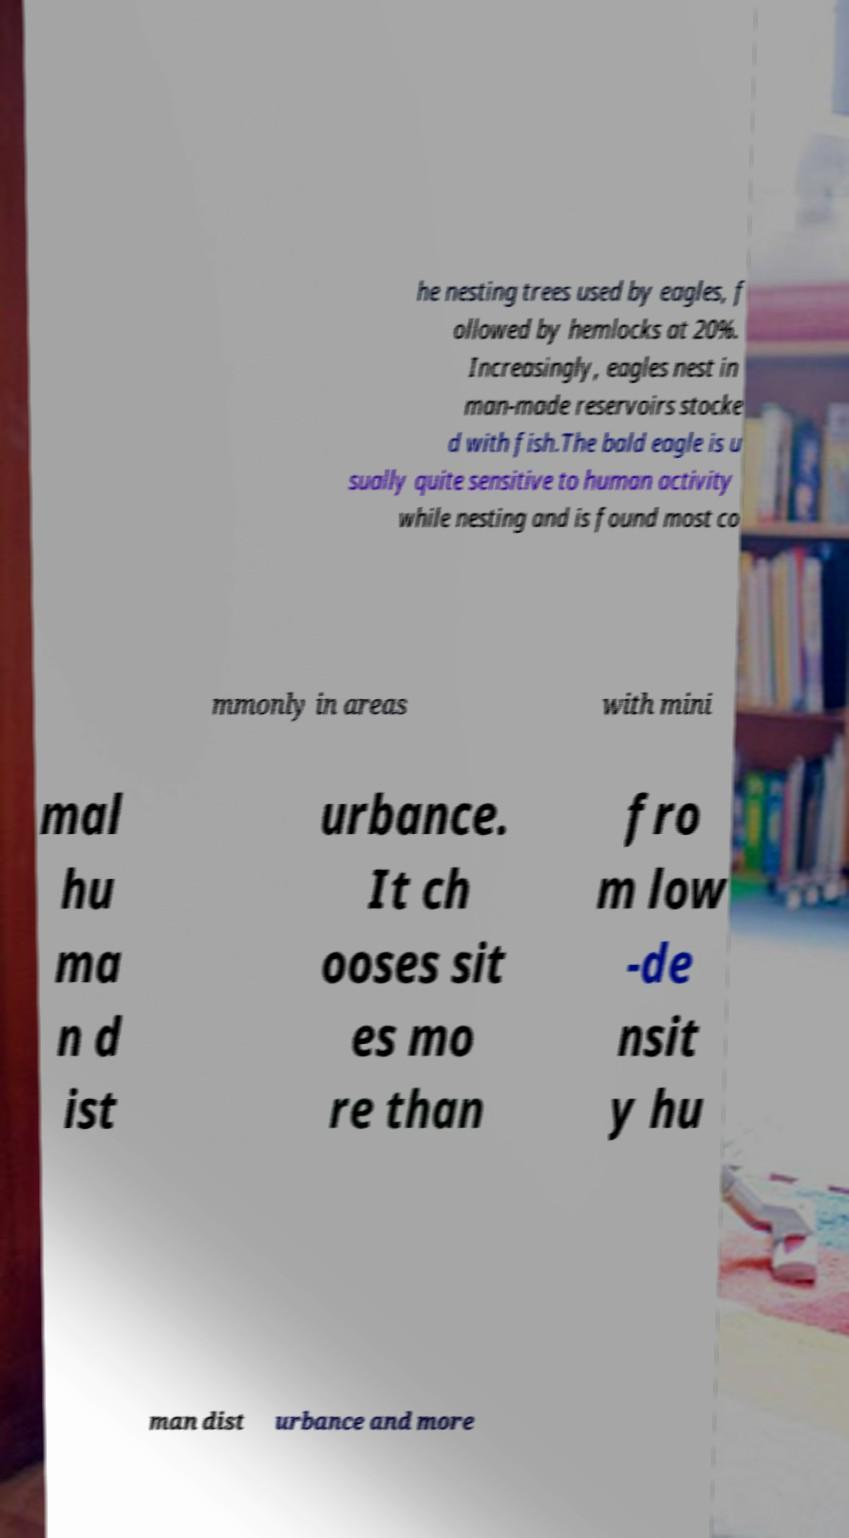Can you read and provide the text displayed in the image?This photo seems to have some interesting text. Can you extract and type it out for me? he nesting trees used by eagles, f ollowed by hemlocks at 20%. Increasingly, eagles nest in man-made reservoirs stocke d with fish.The bald eagle is u sually quite sensitive to human activity while nesting and is found most co mmonly in areas with mini mal hu ma n d ist urbance. It ch ooses sit es mo re than fro m low -de nsit y hu man dist urbance and more 